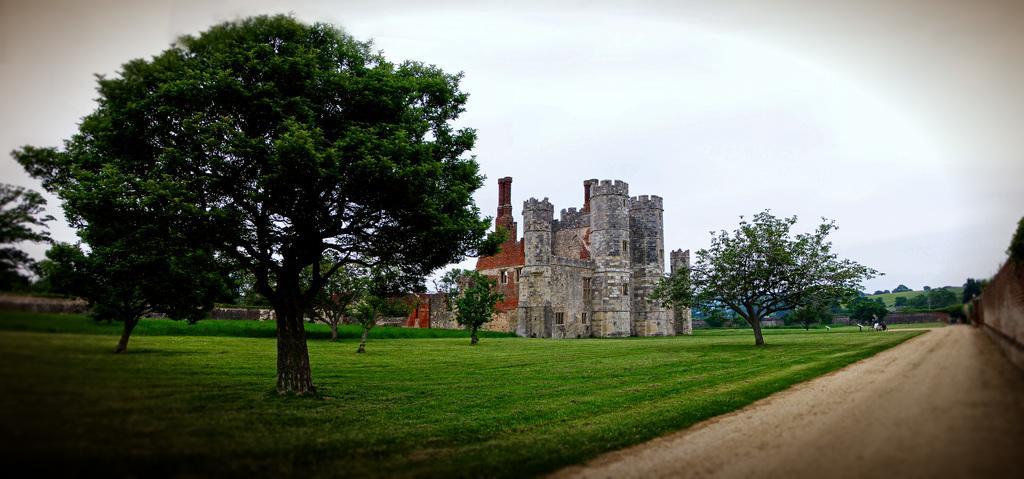In one or two sentences, can you explain what this image depicts? In this image I can see grass ground, number of trees, the sky and a building. I can also see few things over there. 